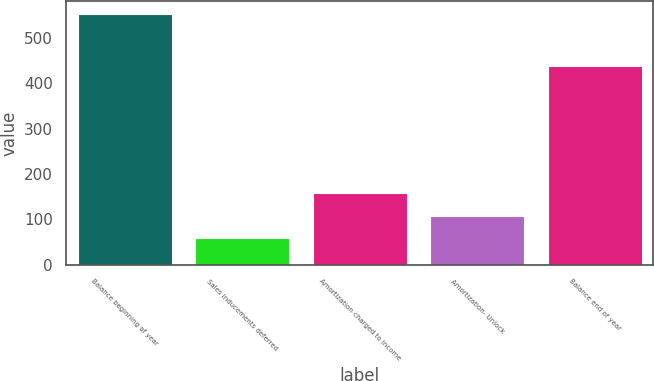<chart> <loc_0><loc_0><loc_500><loc_500><bar_chart><fcel>Balance beginning of year<fcel>Sales inducements deferred<fcel>Amortization charged to income<fcel>Amortization- Unlock<fcel>Balance end of year<nl><fcel>553<fcel>59<fcel>157.8<fcel>108.4<fcel>438<nl></chart> 